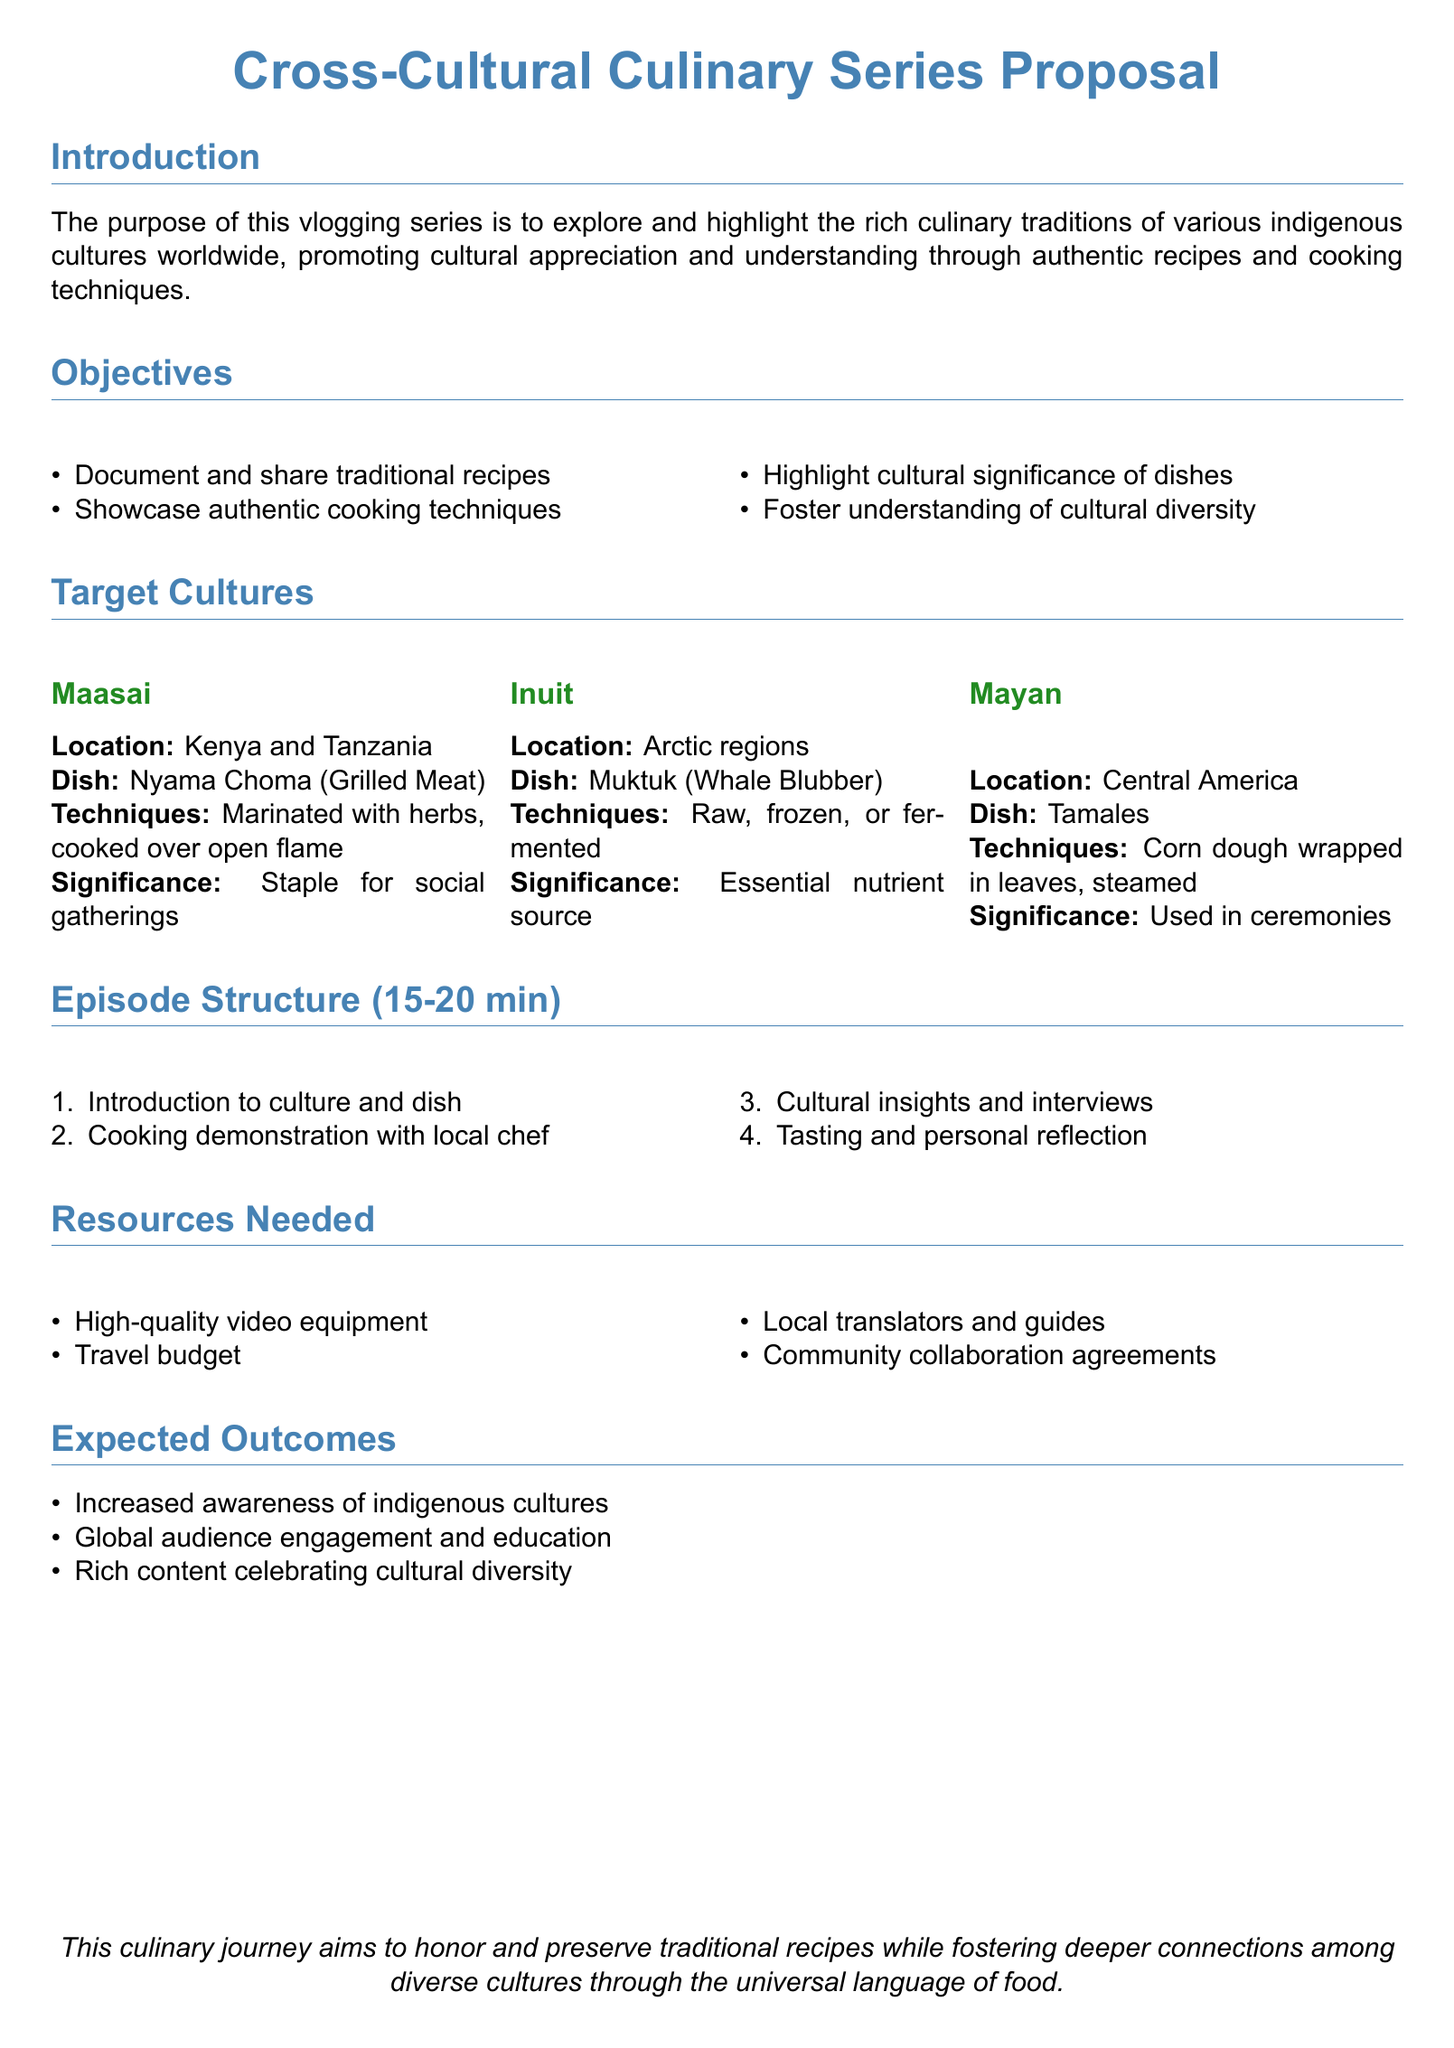What is the main purpose of the culinary series? The main purpose is to explore and highlight the rich culinary traditions of various indigenous cultures worldwide.
Answer: To promote cultural appreciation and understanding through authentic recipes and cooking techniques How many target cultures are listed? The document explicitly states and describes three target cultures.
Answer: Three What is the dish from the Maasai culture? The dish mentioned from the Maasai culture is specifically highlighted in the proposal.
Answer: Nyama Choma What is one of the techniques used in making Tamales? The document describes cooking techniques for Tamales, indicating how they are prepared.
Answer: Steamed What is one expected outcome of the series? The proposal outlines specific outcomes that will result from the series, focusing on cultural impact.
Answer: Increased awareness of indigenous cultures How long is each episode planned to be? The document specifies a range indicating the intended duration for each episode.
Answer: 15-20 minutes Who will conduct the cooking demonstration? The document mentions a specific participant in the cooking demonstration segment of the episodes.
Answer: Local chef What type of agreements are needed for community collaboration? The proposal specifies the type of agreements necessary for involving the communities in the series.
Answer: Community collaboration agreements 